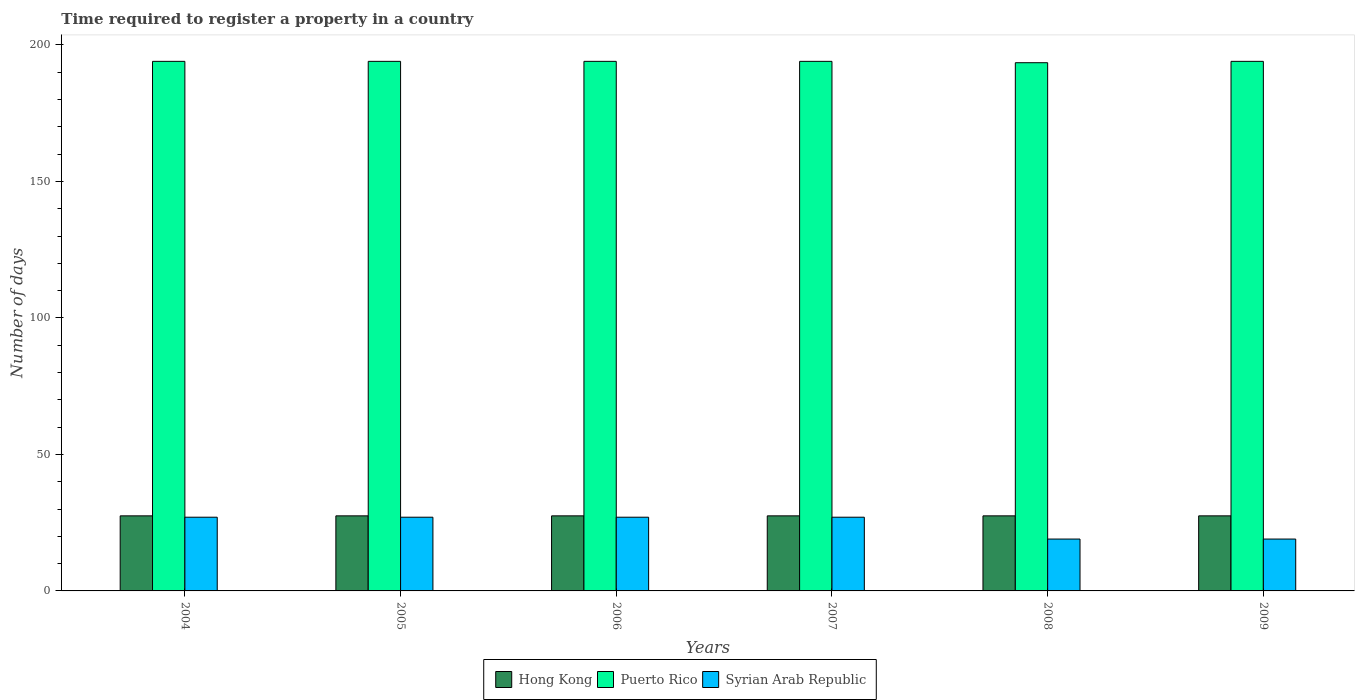Are the number of bars per tick equal to the number of legend labels?
Your answer should be compact. Yes. How many bars are there on the 5th tick from the left?
Provide a succinct answer. 3. What is the label of the 1st group of bars from the left?
Offer a very short reply. 2004. What is the number of days required to register a property in Puerto Rico in 2008?
Ensure brevity in your answer.  193.5. Across all years, what is the maximum number of days required to register a property in Puerto Rico?
Provide a short and direct response. 194. Across all years, what is the minimum number of days required to register a property in Puerto Rico?
Provide a succinct answer. 193.5. In which year was the number of days required to register a property in Hong Kong maximum?
Provide a succinct answer. 2004. What is the total number of days required to register a property in Hong Kong in the graph?
Make the answer very short. 165. What is the difference between the number of days required to register a property in Hong Kong in 2004 and that in 2006?
Your answer should be very brief. 0. What is the difference between the number of days required to register a property in Syrian Arab Republic in 2007 and the number of days required to register a property in Hong Kong in 2009?
Make the answer very short. -0.5. What is the average number of days required to register a property in Puerto Rico per year?
Your answer should be very brief. 193.92. In the year 2004, what is the difference between the number of days required to register a property in Hong Kong and number of days required to register a property in Puerto Rico?
Your answer should be very brief. -166.5. Is the number of days required to register a property in Hong Kong in 2008 less than that in 2009?
Provide a short and direct response. No. What is the difference between the highest and the second highest number of days required to register a property in Syrian Arab Republic?
Provide a succinct answer. 0. What is the difference between the highest and the lowest number of days required to register a property in Hong Kong?
Make the answer very short. 0. In how many years, is the number of days required to register a property in Hong Kong greater than the average number of days required to register a property in Hong Kong taken over all years?
Give a very brief answer. 0. What does the 3rd bar from the left in 2005 represents?
Offer a very short reply. Syrian Arab Republic. What does the 3rd bar from the right in 2007 represents?
Your response must be concise. Hong Kong. Are all the bars in the graph horizontal?
Give a very brief answer. No. How many years are there in the graph?
Your answer should be compact. 6. How are the legend labels stacked?
Provide a succinct answer. Horizontal. What is the title of the graph?
Make the answer very short. Time required to register a property in a country. Does "Japan" appear as one of the legend labels in the graph?
Offer a very short reply. No. What is the label or title of the X-axis?
Offer a very short reply. Years. What is the label or title of the Y-axis?
Keep it short and to the point. Number of days. What is the Number of days of Hong Kong in 2004?
Ensure brevity in your answer.  27.5. What is the Number of days in Puerto Rico in 2004?
Your response must be concise. 194. What is the Number of days in Hong Kong in 2005?
Make the answer very short. 27.5. What is the Number of days in Puerto Rico in 2005?
Your answer should be very brief. 194. What is the Number of days of Hong Kong in 2006?
Offer a very short reply. 27.5. What is the Number of days in Puerto Rico in 2006?
Keep it short and to the point. 194. What is the Number of days in Syrian Arab Republic in 2006?
Offer a very short reply. 27. What is the Number of days of Puerto Rico in 2007?
Your answer should be very brief. 194. What is the Number of days in Hong Kong in 2008?
Offer a terse response. 27.5. What is the Number of days in Puerto Rico in 2008?
Your answer should be compact. 193.5. What is the Number of days of Hong Kong in 2009?
Give a very brief answer. 27.5. What is the Number of days of Puerto Rico in 2009?
Your response must be concise. 194. Across all years, what is the maximum Number of days of Hong Kong?
Keep it short and to the point. 27.5. Across all years, what is the maximum Number of days in Puerto Rico?
Offer a terse response. 194. Across all years, what is the maximum Number of days of Syrian Arab Republic?
Your response must be concise. 27. Across all years, what is the minimum Number of days in Hong Kong?
Offer a very short reply. 27.5. Across all years, what is the minimum Number of days in Puerto Rico?
Your response must be concise. 193.5. What is the total Number of days in Hong Kong in the graph?
Provide a short and direct response. 165. What is the total Number of days in Puerto Rico in the graph?
Provide a short and direct response. 1163.5. What is the total Number of days in Syrian Arab Republic in the graph?
Offer a very short reply. 146. What is the difference between the Number of days of Hong Kong in 2004 and that in 2005?
Your response must be concise. 0. What is the difference between the Number of days in Puerto Rico in 2004 and that in 2006?
Make the answer very short. 0. What is the difference between the Number of days of Syrian Arab Republic in 2004 and that in 2007?
Your answer should be very brief. 0. What is the difference between the Number of days in Puerto Rico in 2004 and that in 2008?
Your response must be concise. 0.5. What is the difference between the Number of days in Hong Kong in 2004 and that in 2009?
Provide a succinct answer. 0. What is the difference between the Number of days in Puerto Rico in 2004 and that in 2009?
Provide a short and direct response. 0. What is the difference between the Number of days in Syrian Arab Republic in 2004 and that in 2009?
Ensure brevity in your answer.  8. What is the difference between the Number of days in Syrian Arab Republic in 2005 and that in 2007?
Your response must be concise. 0. What is the difference between the Number of days in Hong Kong in 2005 and that in 2008?
Keep it short and to the point. 0. What is the difference between the Number of days in Puerto Rico in 2005 and that in 2008?
Your answer should be very brief. 0.5. What is the difference between the Number of days in Syrian Arab Republic in 2005 and that in 2008?
Provide a succinct answer. 8. What is the difference between the Number of days of Puerto Rico in 2005 and that in 2009?
Give a very brief answer. 0. What is the difference between the Number of days in Hong Kong in 2006 and that in 2007?
Your response must be concise. 0. What is the difference between the Number of days of Puerto Rico in 2006 and that in 2008?
Keep it short and to the point. 0.5. What is the difference between the Number of days in Syrian Arab Republic in 2006 and that in 2008?
Offer a very short reply. 8. What is the difference between the Number of days in Hong Kong in 2006 and that in 2009?
Make the answer very short. 0. What is the difference between the Number of days in Hong Kong in 2007 and that in 2008?
Your answer should be compact. 0. What is the difference between the Number of days of Puerto Rico in 2007 and that in 2008?
Provide a short and direct response. 0.5. What is the difference between the Number of days of Puerto Rico in 2008 and that in 2009?
Your answer should be compact. -0.5. What is the difference between the Number of days in Hong Kong in 2004 and the Number of days in Puerto Rico in 2005?
Offer a terse response. -166.5. What is the difference between the Number of days in Puerto Rico in 2004 and the Number of days in Syrian Arab Republic in 2005?
Provide a succinct answer. 167. What is the difference between the Number of days in Hong Kong in 2004 and the Number of days in Puerto Rico in 2006?
Ensure brevity in your answer.  -166.5. What is the difference between the Number of days of Puerto Rico in 2004 and the Number of days of Syrian Arab Republic in 2006?
Your answer should be very brief. 167. What is the difference between the Number of days of Hong Kong in 2004 and the Number of days of Puerto Rico in 2007?
Ensure brevity in your answer.  -166.5. What is the difference between the Number of days of Hong Kong in 2004 and the Number of days of Syrian Arab Republic in 2007?
Your answer should be very brief. 0.5. What is the difference between the Number of days in Puerto Rico in 2004 and the Number of days in Syrian Arab Republic in 2007?
Your answer should be very brief. 167. What is the difference between the Number of days of Hong Kong in 2004 and the Number of days of Puerto Rico in 2008?
Your answer should be compact. -166. What is the difference between the Number of days of Puerto Rico in 2004 and the Number of days of Syrian Arab Republic in 2008?
Offer a very short reply. 175. What is the difference between the Number of days of Hong Kong in 2004 and the Number of days of Puerto Rico in 2009?
Offer a terse response. -166.5. What is the difference between the Number of days in Hong Kong in 2004 and the Number of days in Syrian Arab Republic in 2009?
Give a very brief answer. 8.5. What is the difference between the Number of days of Puerto Rico in 2004 and the Number of days of Syrian Arab Republic in 2009?
Offer a terse response. 175. What is the difference between the Number of days of Hong Kong in 2005 and the Number of days of Puerto Rico in 2006?
Keep it short and to the point. -166.5. What is the difference between the Number of days in Puerto Rico in 2005 and the Number of days in Syrian Arab Republic in 2006?
Offer a very short reply. 167. What is the difference between the Number of days of Hong Kong in 2005 and the Number of days of Puerto Rico in 2007?
Provide a succinct answer. -166.5. What is the difference between the Number of days in Puerto Rico in 2005 and the Number of days in Syrian Arab Republic in 2007?
Give a very brief answer. 167. What is the difference between the Number of days of Hong Kong in 2005 and the Number of days of Puerto Rico in 2008?
Provide a succinct answer. -166. What is the difference between the Number of days of Hong Kong in 2005 and the Number of days of Syrian Arab Republic in 2008?
Your answer should be very brief. 8.5. What is the difference between the Number of days in Puerto Rico in 2005 and the Number of days in Syrian Arab Republic in 2008?
Your answer should be very brief. 175. What is the difference between the Number of days of Hong Kong in 2005 and the Number of days of Puerto Rico in 2009?
Offer a terse response. -166.5. What is the difference between the Number of days of Puerto Rico in 2005 and the Number of days of Syrian Arab Republic in 2009?
Provide a succinct answer. 175. What is the difference between the Number of days of Hong Kong in 2006 and the Number of days of Puerto Rico in 2007?
Your response must be concise. -166.5. What is the difference between the Number of days in Hong Kong in 2006 and the Number of days in Syrian Arab Republic in 2007?
Make the answer very short. 0.5. What is the difference between the Number of days of Puerto Rico in 2006 and the Number of days of Syrian Arab Republic in 2007?
Your response must be concise. 167. What is the difference between the Number of days in Hong Kong in 2006 and the Number of days in Puerto Rico in 2008?
Ensure brevity in your answer.  -166. What is the difference between the Number of days of Puerto Rico in 2006 and the Number of days of Syrian Arab Republic in 2008?
Provide a succinct answer. 175. What is the difference between the Number of days of Hong Kong in 2006 and the Number of days of Puerto Rico in 2009?
Give a very brief answer. -166.5. What is the difference between the Number of days in Puerto Rico in 2006 and the Number of days in Syrian Arab Republic in 2009?
Offer a terse response. 175. What is the difference between the Number of days in Hong Kong in 2007 and the Number of days in Puerto Rico in 2008?
Your answer should be compact. -166. What is the difference between the Number of days of Hong Kong in 2007 and the Number of days of Syrian Arab Republic in 2008?
Ensure brevity in your answer.  8.5. What is the difference between the Number of days in Puerto Rico in 2007 and the Number of days in Syrian Arab Republic in 2008?
Your response must be concise. 175. What is the difference between the Number of days of Hong Kong in 2007 and the Number of days of Puerto Rico in 2009?
Keep it short and to the point. -166.5. What is the difference between the Number of days of Puerto Rico in 2007 and the Number of days of Syrian Arab Republic in 2009?
Ensure brevity in your answer.  175. What is the difference between the Number of days in Hong Kong in 2008 and the Number of days in Puerto Rico in 2009?
Ensure brevity in your answer.  -166.5. What is the difference between the Number of days in Puerto Rico in 2008 and the Number of days in Syrian Arab Republic in 2009?
Offer a very short reply. 174.5. What is the average Number of days in Hong Kong per year?
Ensure brevity in your answer.  27.5. What is the average Number of days of Puerto Rico per year?
Offer a very short reply. 193.92. What is the average Number of days of Syrian Arab Republic per year?
Keep it short and to the point. 24.33. In the year 2004, what is the difference between the Number of days of Hong Kong and Number of days of Puerto Rico?
Your answer should be compact. -166.5. In the year 2004, what is the difference between the Number of days in Hong Kong and Number of days in Syrian Arab Republic?
Make the answer very short. 0.5. In the year 2004, what is the difference between the Number of days of Puerto Rico and Number of days of Syrian Arab Republic?
Offer a terse response. 167. In the year 2005, what is the difference between the Number of days of Hong Kong and Number of days of Puerto Rico?
Provide a succinct answer. -166.5. In the year 2005, what is the difference between the Number of days of Puerto Rico and Number of days of Syrian Arab Republic?
Give a very brief answer. 167. In the year 2006, what is the difference between the Number of days in Hong Kong and Number of days in Puerto Rico?
Your response must be concise. -166.5. In the year 2006, what is the difference between the Number of days in Hong Kong and Number of days in Syrian Arab Republic?
Your response must be concise. 0.5. In the year 2006, what is the difference between the Number of days of Puerto Rico and Number of days of Syrian Arab Republic?
Your answer should be very brief. 167. In the year 2007, what is the difference between the Number of days of Hong Kong and Number of days of Puerto Rico?
Provide a short and direct response. -166.5. In the year 2007, what is the difference between the Number of days in Puerto Rico and Number of days in Syrian Arab Republic?
Your answer should be compact. 167. In the year 2008, what is the difference between the Number of days of Hong Kong and Number of days of Puerto Rico?
Ensure brevity in your answer.  -166. In the year 2008, what is the difference between the Number of days of Hong Kong and Number of days of Syrian Arab Republic?
Ensure brevity in your answer.  8.5. In the year 2008, what is the difference between the Number of days in Puerto Rico and Number of days in Syrian Arab Republic?
Keep it short and to the point. 174.5. In the year 2009, what is the difference between the Number of days of Hong Kong and Number of days of Puerto Rico?
Your answer should be compact. -166.5. In the year 2009, what is the difference between the Number of days in Hong Kong and Number of days in Syrian Arab Republic?
Provide a succinct answer. 8.5. In the year 2009, what is the difference between the Number of days in Puerto Rico and Number of days in Syrian Arab Republic?
Your response must be concise. 175. What is the ratio of the Number of days in Syrian Arab Republic in 2004 to that in 2005?
Provide a short and direct response. 1. What is the ratio of the Number of days of Syrian Arab Republic in 2004 to that in 2006?
Your answer should be compact. 1. What is the ratio of the Number of days in Hong Kong in 2004 to that in 2007?
Your answer should be very brief. 1. What is the ratio of the Number of days in Syrian Arab Republic in 2004 to that in 2008?
Give a very brief answer. 1.42. What is the ratio of the Number of days in Syrian Arab Republic in 2004 to that in 2009?
Keep it short and to the point. 1.42. What is the ratio of the Number of days in Puerto Rico in 2005 to that in 2006?
Give a very brief answer. 1. What is the ratio of the Number of days of Puerto Rico in 2005 to that in 2008?
Your response must be concise. 1. What is the ratio of the Number of days in Syrian Arab Republic in 2005 to that in 2008?
Make the answer very short. 1.42. What is the ratio of the Number of days of Syrian Arab Republic in 2005 to that in 2009?
Provide a short and direct response. 1.42. What is the ratio of the Number of days in Hong Kong in 2006 to that in 2007?
Give a very brief answer. 1. What is the ratio of the Number of days in Hong Kong in 2006 to that in 2008?
Provide a short and direct response. 1. What is the ratio of the Number of days in Syrian Arab Republic in 2006 to that in 2008?
Give a very brief answer. 1.42. What is the ratio of the Number of days of Syrian Arab Republic in 2006 to that in 2009?
Offer a terse response. 1.42. What is the ratio of the Number of days of Syrian Arab Republic in 2007 to that in 2008?
Make the answer very short. 1.42. What is the ratio of the Number of days of Puerto Rico in 2007 to that in 2009?
Your answer should be very brief. 1. What is the ratio of the Number of days in Syrian Arab Republic in 2007 to that in 2009?
Your answer should be very brief. 1.42. What is the ratio of the Number of days in Hong Kong in 2008 to that in 2009?
Your answer should be compact. 1. What is the ratio of the Number of days of Puerto Rico in 2008 to that in 2009?
Provide a short and direct response. 1. What is the difference between the highest and the second highest Number of days in Hong Kong?
Make the answer very short. 0. What is the difference between the highest and the second highest Number of days of Syrian Arab Republic?
Ensure brevity in your answer.  0. What is the difference between the highest and the lowest Number of days of Syrian Arab Republic?
Your answer should be compact. 8. 